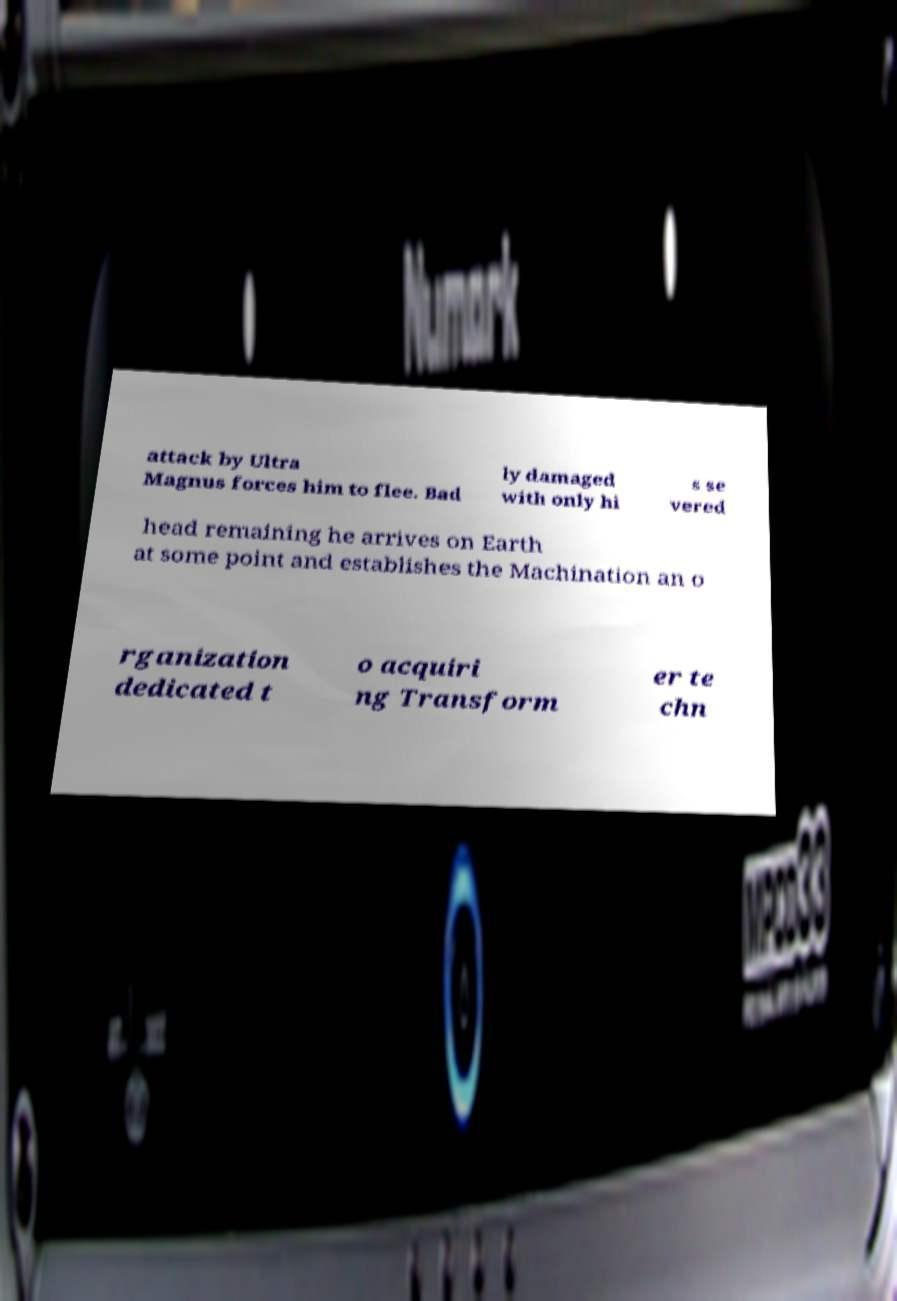I need the written content from this picture converted into text. Can you do that? attack by Ultra Magnus forces him to flee. Bad ly damaged with only hi s se vered head remaining he arrives on Earth at some point and establishes the Machination an o rganization dedicated t o acquiri ng Transform er te chn 